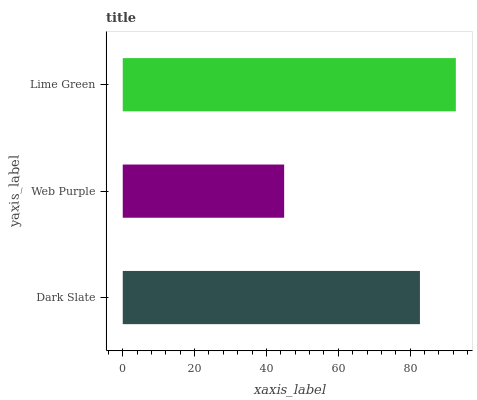Is Web Purple the minimum?
Answer yes or no. Yes. Is Lime Green the maximum?
Answer yes or no. Yes. Is Lime Green the minimum?
Answer yes or no. No. Is Web Purple the maximum?
Answer yes or no. No. Is Lime Green greater than Web Purple?
Answer yes or no. Yes. Is Web Purple less than Lime Green?
Answer yes or no. Yes. Is Web Purple greater than Lime Green?
Answer yes or no. No. Is Lime Green less than Web Purple?
Answer yes or no. No. Is Dark Slate the high median?
Answer yes or no. Yes. Is Dark Slate the low median?
Answer yes or no. Yes. Is Web Purple the high median?
Answer yes or no. No. Is Web Purple the low median?
Answer yes or no. No. 